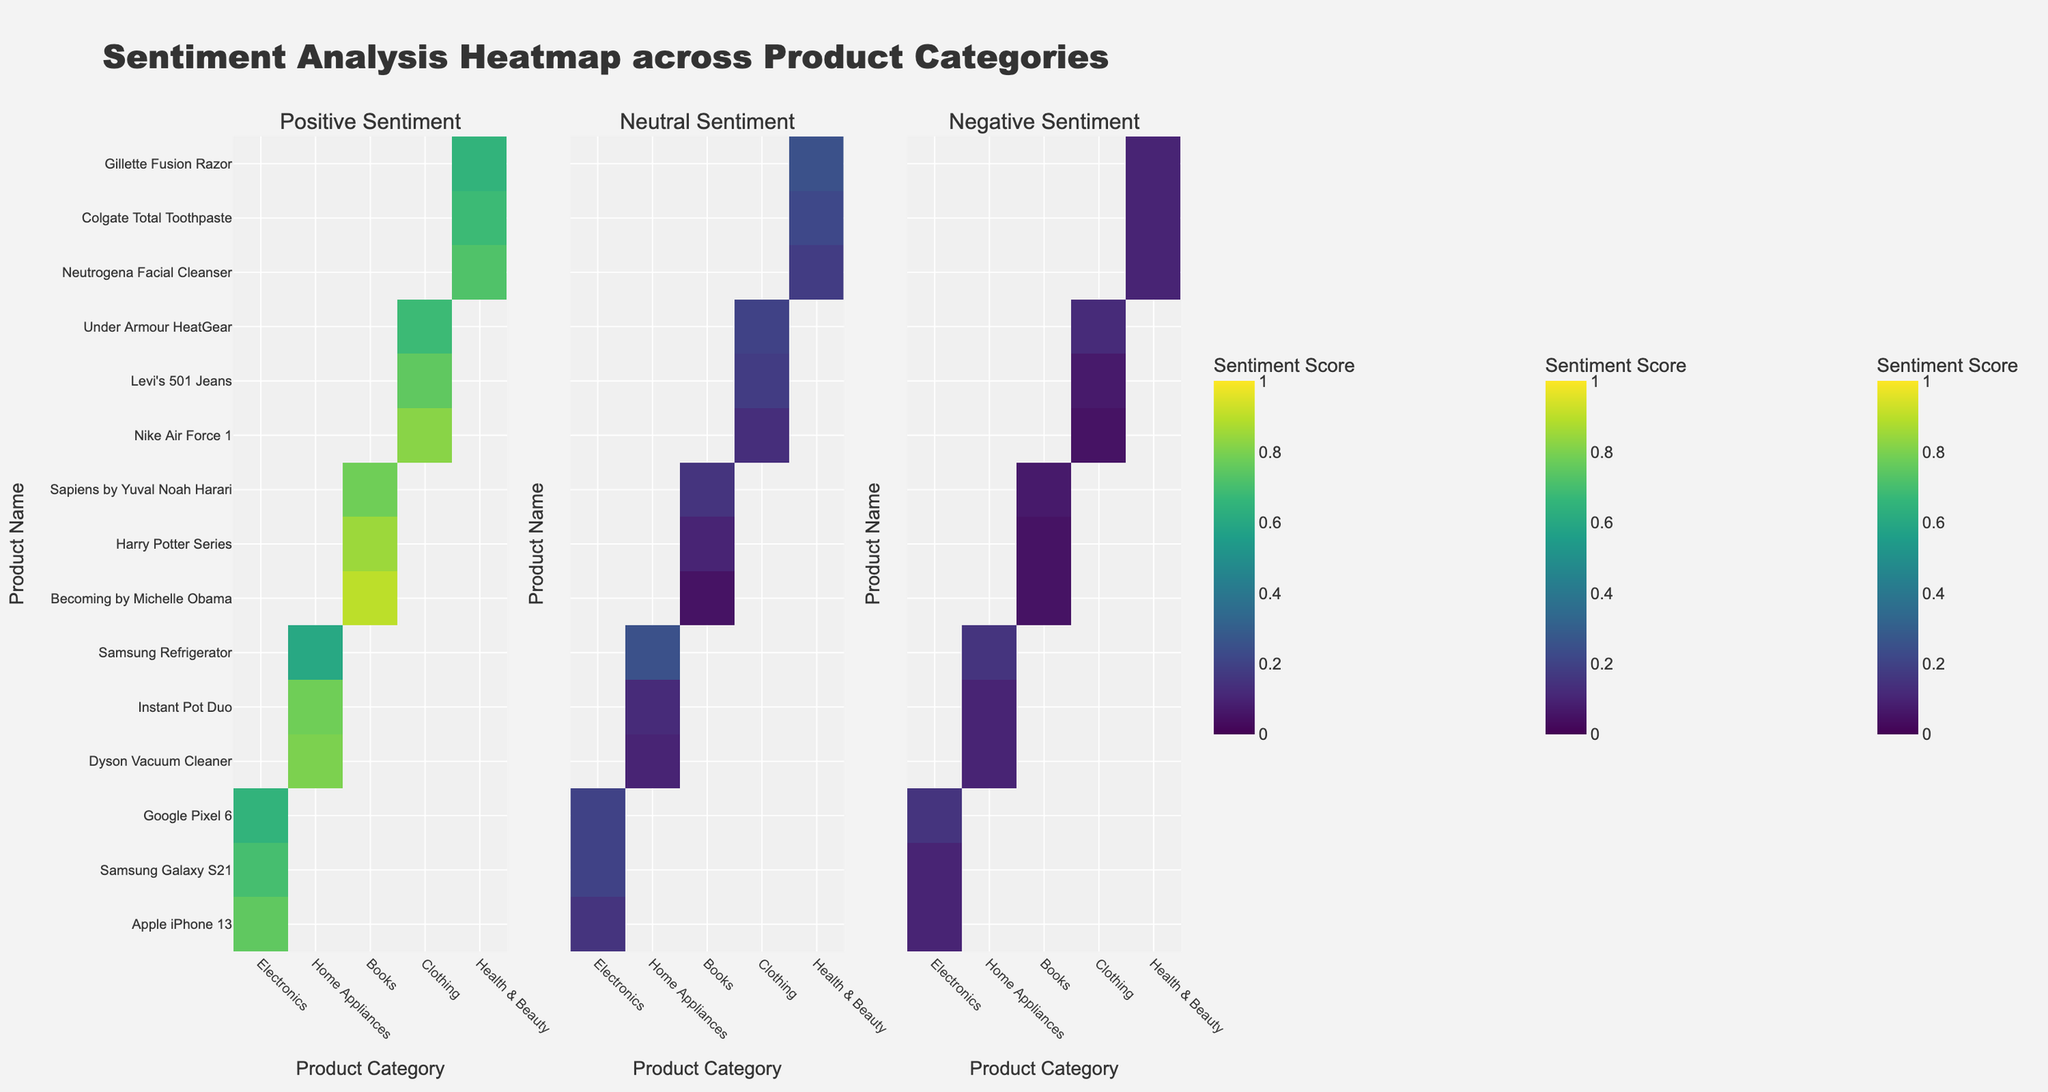What's the title of the figure? The title appears at the top of the figure and provides an overview of what the heatmap represents. It is usually bold and prominently displayed.
Answer: "Sentiment Analysis Heatmap across Product Categories" How many subplots are there in the figure? Observing the layout, the figure is divided into three distinct sections, or subplots.
Answer: 3 Which product in the Electronics category has the highest positive sentiment score? Observing the color intensity (bright yellow) in the first subplot for the Electronics category, Apple iPhone 13 has the highest positive sentiment score.
Answer: Apple iPhone 13 What is the neutral sentiment score for the Samsung Refrigerator? Locate the Samsung Refrigerator in the y-axis and move across to the second subplot (Neutral Sentiment) to check the color intensity aligns with a score of 0.25.
Answer: 0.25 Which product category has the most varied negative sentiment scores across its products? By examining the third subplot's color variations, Electronics and Home Appliances show significant differences in negative sentiment scores with varying intensities.
Answer: Home Appliances What's the average positive sentiment score for Books category products? Sum the positive sentiment scores for all Books products (0.90, 0.85, 0.78) and divide by the number of products (3). Calculation: (0.90 + 0.85 + 0.78) / 3 = 2.53 / 3
Answer: 0.8433 Which health & beauty product has the lowest neutral sentiment score? Among the Health & Beauty items in the second subplot, locate the one with the darkest corresponding intensity for the lowest neutral sentiment score. This is Neutrogena Facial Cleanser with a score of 0.18.
Answer: Neutrogena Facial Cleanser Compare the positive sentiment score of Nike Air Force 1 and Under Armour HeatGear. Which one is higher? Locate both products in the y-axis and check their corresponding color intensities in the first subplot (Positive Sentiment). Nike Air Force 1 has a higher score (0.82) compared to Under Armour HeatGear (0.68).
Answer: Nike Air Force 1 What can you infer about the negative sentiment scores for Books category products? Observing the third subplot for all Books category products, their negative sentiment scores are relatively low (0.05 to 0.07), indicated by the less intense colors.
Answer: Low negative sentiment Which product category tends to have more neutral sentiment scores? The second subplot (Neutral Sentiment) shows that Health & Beauty and Electronics have more intense colors, indicating generally higher neutral sentiment scores.
Answer: Health & Beauty and Electronics 